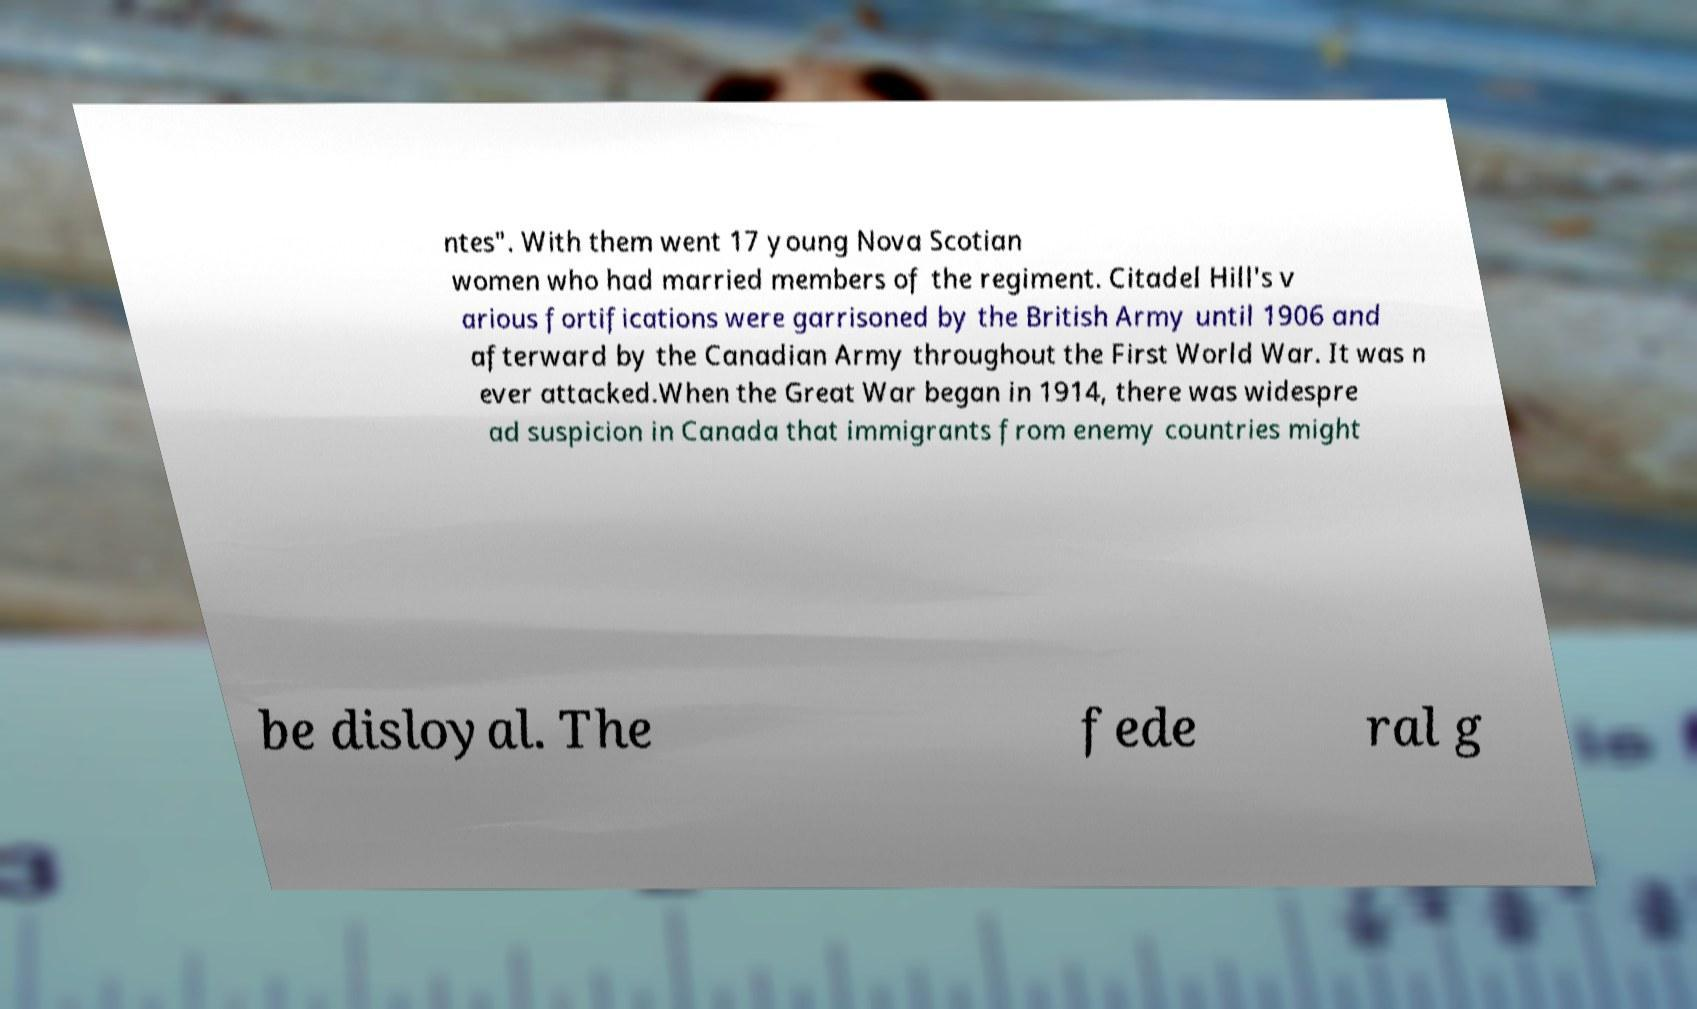I need the written content from this picture converted into text. Can you do that? ntes". With them went 17 young Nova Scotian women who had married members of the regiment. Citadel Hill's v arious fortifications were garrisoned by the British Army until 1906 and afterward by the Canadian Army throughout the First World War. It was n ever attacked.When the Great War began in 1914, there was widespre ad suspicion in Canada that immigrants from enemy countries might be disloyal. The fede ral g 